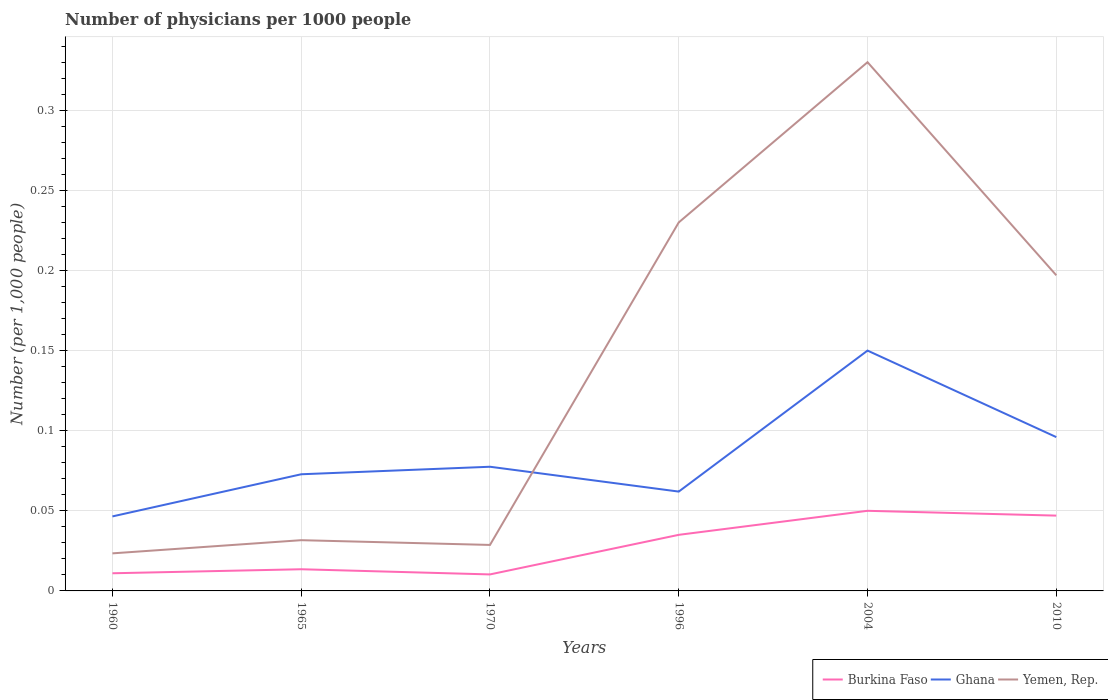How many different coloured lines are there?
Give a very brief answer. 3. Does the line corresponding to Yemen, Rep. intersect with the line corresponding to Ghana?
Make the answer very short. Yes. Is the number of lines equal to the number of legend labels?
Give a very brief answer. Yes. Across all years, what is the maximum number of physicians in Yemen, Rep.?
Offer a terse response. 0.02. What is the total number of physicians in Yemen, Rep. in the graph?
Offer a very short reply. -0.21. What is the difference between the highest and the second highest number of physicians in Ghana?
Make the answer very short. 0.1. How many lines are there?
Provide a succinct answer. 3. Are the values on the major ticks of Y-axis written in scientific E-notation?
Your response must be concise. No. Where does the legend appear in the graph?
Offer a very short reply. Bottom right. How many legend labels are there?
Your answer should be very brief. 3. What is the title of the graph?
Give a very brief answer. Number of physicians per 1000 people. Does "Spain" appear as one of the legend labels in the graph?
Your response must be concise. No. What is the label or title of the Y-axis?
Offer a very short reply. Number (per 1,0 people). What is the Number (per 1,000 people) of Burkina Faso in 1960?
Provide a succinct answer. 0.01. What is the Number (per 1,000 people) of Ghana in 1960?
Your answer should be compact. 0.05. What is the Number (per 1,000 people) of Yemen, Rep. in 1960?
Keep it short and to the point. 0.02. What is the Number (per 1,000 people) in Burkina Faso in 1965?
Provide a succinct answer. 0.01. What is the Number (per 1,000 people) of Ghana in 1965?
Keep it short and to the point. 0.07. What is the Number (per 1,000 people) in Yemen, Rep. in 1965?
Make the answer very short. 0.03. What is the Number (per 1,000 people) of Burkina Faso in 1970?
Make the answer very short. 0.01. What is the Number (per 1,000 people) in Ghana in 1970?
Ensure brevity in your answer.  0.08. What is the Number (per 1,000 people) in Yemen, Rep. in 1970?
Give a very brief answer. 0.03. What is the Number (per 1,000 people) of Burkina Faso in 1996?
Keep it short and to the point. 0.04. What is the Number (per 1,000 people) in Ghana in 1996?
Keep it short and to the point. 0.06. What is the Number (per 1,000 people) of Yemen, Rep. in 1996?
Your response must be concise. 0.23. What is the Number (per 1,000 people) in Burkina Faso in 2004?
Offer a terse response. 0.05. What is the Number (per 1,000 people) in Yemen, Rep. in 2004?
Provide a short and direct response. 0.33. What is the Number (per 1,000 people) of Burkina Faso in 2010?
Keep it short and to the point. 0.05. What is the Number (per 1,000 people) in Ghana in 2010?
Your answer should be very brief. 0.1. What is the Number (per 1,000 people) in Yemen, Rep. in 2010?
Your response must be concise. 0.2. Across all years, what is the maximum Number (per 1,000 people) in Burkina Faso?
Give a very brief answer. 0.05. Across all years, what is the maximum Number (per 1,000 people) of Ghana?
Offer a terse response. 0.15. Across all years, what is the maximum Number (per 1,000 people) of Yemen, Rep.?
Make the answer very short. 0.33. Across all years, what is the minimum Number (per 1,000 people) of Burkina Faso?
Your answer should be very brief. 0.01. Across all years, what is the minimum Number (per 1,000 people) in Ghana?
Provide a short and direct response. 0.05. Across all years, what is the minimum Number (per 1,000 people) of Yemen, Rep.?
Provide a short and direct response. 0.02. What is the total Number (per 1,000 people) of Burkina Faso in the graph?
Offer a terse response. 0.17. What is the total Number (per 1,000 people) in Ghana in the graph?
Keep it short and to the point. 0.5. What is the total Number (per 1,000 people) of Yemen, Rep. in the graph?
Your answer should be compact. 0.84. What is the difference between the Number (per 1,000 people) in Burkina Faso in 1960 and that in 1965?
Ensure brevity in your answer.  -0. What is the difference between the Number (per 1,000 people) of Ghana in 1960 and that in 1965?
Keep it short and to the point. -0.03. What is the difference between the Number (per 1,000 people) in Yemen, Rep. in 1960 and that in 1965?
Your answer should be compact. -0.01. What is the difference between the Number (per 1,000 people) in Burkina Faso in 1960 and that in 1970?
Your answer should be compact. 0. What is the difference between the Number (per 1,000 people) of Ghana in 1960 and that in 1970?
Make the answer very short. -0.03. What is the difference between the Number (per 1,000 people) in Yemen, Rep. in 1960 and that in 1970?
Your answer should be compact. -0.01. What is the difference between the Number (per 1,000 people) in Burkina Faso in 1960 and that in 1996?
Your answer should be compact. -0.02. What is the difference between the Number (per 1,000 people) of Ghana in 1960 and that in 1996?
Provide a short and direct response. -0.02. What is the difference between the Number (per 1,000 people) in Yemen, Rep. in 1960 and that in 1996?
Your answer should be compact. -0.21. What is the difference between the Number (per 1,000 people) in Burkina Faso in 1960 and that in 2004?
Your response must be concise. -0.04. What is the difference between the Number (per 1,000 people) in Ghana in 1960 and that in 2004?
Make the answer very short. -0.1. What is the difference between the Number (per 1,000 people) of Yemen, Rep. in 1960 and that in 2004?
Your answer should be compact. -0.31. What is the difference between the Number (per 1,000 people) in Burkina Faso in 1960 and that in 2010?
Ensure brevity in your answer.  -0.04. What is the difference between the Number (per 1,000 people) of Ghana in 1960 and that in 2010?
Provide a short and direct response. -0.05. What is the difference between the Number (per 1,000 people) in Yemen, Rep. in 1960 and that in 2010?
Your response must be concise. -0.17. What is the difference between the Number (per 1,000 people) of Burkina Faso in 1965 and that in 1970?
Your answer should be very brief. 0. What is the difference between the Number (per 1,000 people) in Ghana in 1965 and that in 1970?
Offer a terse response. -0. What is the difference between the Number (per 1,000 people) in Yemen, Rep. in 1965 and that in 1970?
Provide a short and direct response. 0. What is the difference between the Number (per 1,000 people) of Burkina Faso in 1965 and that in 1996?
Provide a short and direct response. -0.02. What is the difference between the Number (per 1,000 people) of Ghana in 1965 and that in 1996?
Offer a very short reply. 0.01. What is the difference between the Number (per 1,000 people) of Yemen, Rep. in 1965 and that in 1996?
Your response must be concise. -0.2. What is the difference between the Number (per 1,000 people) in Burkina Faso in 1965 and that in 2004?
Make the answer very short. -0.04. What is the difference between the Number (per 1,000 people) of Ghana in 1965 and that in 2004?
Give a very brief answer. -0.08. What is the difference between the Number (per 1,000 people) of Yemen, Rep. in 1965 and that in 2004?
Your answer should be compact. -0.3. What is the difference between the Number (per 1,000 people) of Burkina Faso in 1965 and that in 2010?
Make the answer very short. -0.03. What is the difference between the Number (per 1,000 people) of Ghana in 1965 and that in 2010?
Your answer should be compact. -0.02. What is the difference between the Number (per 1,000 people) of Yemen, Rep. in 1965 and that in 2010?
Provide a succinct answer. -0.17. What is the difference between the Number (per 1,000 people) in Burkina Faso in 1970 and that in 1996?
Provide a succinct answer. -0.02. What is the difference between the Number (per 1,000 people) in Ghana in 1970 and that in 1996?
Offer a terse response. 0.02. What is the difference between the Number (per 1,000 people) in Yemen, Rep. in 1970 and that in 1996?
Your answer should be very brief. -0.2. What is the difference between the Number (per 1,000 people) in Burkina Faso in 1970 and that in 2004?
Keep it short and to the point. -0.04. What is the difference between the Number (per 1,000 people) in Ghana in 1970 and that in 2004?
Offer a terse response. -0.07. What is the difference between the Number (per 1,000 people) of Yemen, Rep. in 1970 and that in 2004?
Your answer should be very brief. -0.3. What is the difference between the Number (per 1,000 people) in Burkina Faso in 1970 and that in 2010?
Offer a very short reply. -0.04. What is the difference between the Number (per 1,000 people) in Ghana in 1970 and that in 2010?
Ensure brevity in your answer.  -0.02. What is the difference between the Number (per 1,000 people) in Yemen, Rep. in 1970 and that in 2010?
Your answer should be compact. -0.17. What is the difference between the Number (per 1,000 people) of Burkina Faso in 1996 and that in 2004?
Your answer should be compact. -0.01. What is the difference between the Number (per 1,000 people) in Ghana in 1996 and that in 2004?
Offer a terse response. -0.09. What is the difference between the Number (per 1,000 people) in Yemen, Rep. in 1996 and that in 2004?
Offer a terse response. -0.1. What is the difference between the Number (per 1,000 people) in Burkina Faso in 1996 and that in 2010?
Make the answer very short. -0.01. What is the difference between the Number (per 1,000 people) in Ghana in 1996 and that in 2010?
Provide a succinct answer. -0.03. What is the difference between the Number (per 1,000 people) in Yemen, Rep. in 1996 and that in 2010?
Ensure brevity in your answer.  0.03. What is the difference between the Number (per 1,000 people) of Burkina Faso in 2004 and that in 2010?
Ensure brevity in your answer.  0. What is the difference between the Number (per 1,000 people) in Ghana in 2004 and that in 2010?
Keep it short and to the point. 0.05. What is the difference between the Number (per 1,000 people) of Yemen, Rep. in 2004 and that in 2010?
Offer a very short reply. 0.13. What is the difference between the Number (per 1,000 people) in Burkina Faso in 1960 and the Number (per 1,000 people) in Ghana in 1965?
Your answer should be very brief. -0.06. What is the difference between the Number (per 1,000 people) in Burkina Faso in 1960 and the Number (per 1,000 people) in Yemen, Rep. in 1965?
Provide a short and direct response. -0.02. What is the difference between the Number (per 1,000 people) of Ghana in 1960 and the Number (per 1,000 people) of Yemen, Rep. in 1965?
Keep it short and to the point. 0.01. What is the difference between the Number (per 1,000 people) of Burkina Faso in 1960 and the Number (per 1,000 people) of Ghana in 1970?
Offer a terse response. -0.07. What is the difference between the Number (per 1,000 people) of Burkina Faso in 1960 and the Number (per 1,000 people) of Yemen, Rep. in 1970?
Your response must be concise. -0.02. What is the difference between the Number (per 1,000 people) of Ghana in 1960 and the Number (per 1,000 people) of Yemen, Rep. in 1970?
Keep it short and to the point. 0.02. What is the difference between the Number (per 1,000 people) of Burkina Faso in 1960 and the Number (per 1,000 people) of Ghana in 1996?
Provide a short and direct response. -0.05. What is the difference between the Number (per 1,000 people) in Burkina Faso in 1960 and the Number (per 1,000 people) in Yemen, Rep. in 1996?
Keep it short and to the point. -0.22. What is the difference between the Number (per 1,000 people) of Ghana in 1960 and the Number (per 1,000 people) of Yemen, Rep. in 1996?
Provide a short and direct response. -0.18. What is the difference between the Number (per 1,000 people) in Burkina Faso in 1960 and the Number (per 1,000 people) in Ghana in 2004?
Provide a succinct answer. -0.14. What is the difference between the Number (per 1,000 people) of Burkina Faso in 1960 and the Number (per 1,000 people) of Yemen, Rep. in 2004?
Offer a terse response. -0.32. What is the difference between the Number (per 1,000 people) of Ghana in 1960 and the Number (per 1,000 people) of Yemen, Rep. in 2004?
Give a very brief answer. -0.28. What is the difference between the Number (per 1,000 people) in Burkina Faso in 1960 and the Number (per 1,000 people) in Ghana in 2010?
Your answer should be compact. -0.09. What is the difference between the Number (per 1,000 people) in Burkina Faso in 1960 and the Number (per 1,000 people) in Yemen, Rep. in 2010?
Provide a short and direct response. -0.19. What is the difference between the Number (per 1,000 people) of Ghana in 1960 and the Number (per 1,000 people) of Yemen, Rep. in 2010?
Make the answer very short. -0.15. What is the difference between the Number (per 1,000 people) of Burkina Faso in 1965 and the Number (per 1,000 people) of Ghana in 1970?
Ensure brevity in your answer.  -0.06. What is the difference between the Number (per 1,000 people) in Burkina Faso in 1965 and the Number (per 1,000 people) in Yemen, Rep. in 1970?
Give a very brief answer. -0.02. What is the difference between the Number (per 1,000 people) of Ghana in 1965 and the Number (per 1,000 people) of Yemen, Rep. in 1970?
Offer a terse response. 0.04. What is the difference between the Number (per 1,000 people) of Burkina Faso in 1965 and the Number (per 1,000 people) of Ghana in 1996?
Your answer should be very brief. -0.05. What is the difference between the Number (per 1,000 people) in Burkina Faso in 1965 and the Number (per 1,000 people) in Yemen, Rep. in 1996?
Your response must be concise. -0.22. What is the difference between the Number (per 1,000 people) in Ghana in 1965 and the Number (per 1,000 people) in Yemen, Rep. in 1996?
Your response must be concise. -0.16. What is the difference between the Number (per 1,000 people) in Burkina Faso in 1965 and the Number (per 1,000 people) in Ghana in 2004?
Offer a terse response. -0.14. What is the difference between the Number (per 1,000 people) in Burkina Faso in 1965 and the Number (per 1,000 people) in Yemen, Rep. in 2004?
Give a very brief answer. -0.32. What is the difference between the Number (per 1,000 people) in Ghana in 1965 and the Number (per 1,000 people) in Yemen, Rep. in 2004?
Give a very brief answer. -0.26. What is the difference between the Number (per 1,000 people) in Burkina Faso in 1965 and the Number (per 1,000 people) in Ghana in 2010?
Ensure brevity in your answer.  -0.08. What is the difference between the Number (per 1,000 people) in Burkina Faso in 1965 and the Number (per 1,000 people) in Yemen, Rep. in 2010?
Keep it short and to the point. -0.18. What is the difference between the Number (per 1,000 people) in Ghana in 1965 and the Number (per 1,000 people) in Yemen, Rep. in 2010?
Provide a succinct answer. -0.12. What is the difference between the Number (per 1,000 people) of Burkina Faso in 1970 and the Number (per 1,000 people) of Ghana in 1996?
Give a very brief answer. -0.05. What is the difference between the Number (per 1,000 people) of Burkina Faso in 1970 and the Number (per 1,000 people) of Yemen, Rep. in 1996?
Make the answer very short. -0.22. What is the difference between the Number (per 1,000 people) in Ghana in 1970 and the Number (per 1,000 people) in Yemen, Rep. in 1996?
Ensure brevity in your answer.  -0.15. What is the difference between the Number (per 1,000 people) of Burkina Faso in 1970 and the Number (per 1,000 people) of Ghana in 2004?
Your response must be concise. -0.14. What is the difference between the Number (per 1,000 people) of Burkina Faso in 1970 and the Number (per 1,000 people) of Yemen, Rep. in 2004?
Your answer should be very brief. -0.32. What is the difference between the Number (per 1,000 people) of Ghana in 1970 and the Number (per 1,000 people) of Yemen, Rep. in 2004?
Offer a terse response. -0.25. What is the difference between the Number (per 1,000 people) in Burkina Faso in 1970 and the Number (per 1,000 people) in Ghana in 2010?
Offer a terse response. -0.09. What is the difference between the Number (per 1,000 people) in Burkina Faso in 1970 and the Number (per 1,000 people) in Yemen, Rep. in 2010?
Offer a very short reply. -0.19. What is the difference between the Number (per 1,000 people) of Ghana in 1970 and the Number (per 1,000 people) of Yemen, Rep. in 2010?
Ensure brevity in your answer.  -0.12. What is the difference between the Number (per 1,000 people) of Burkina Faso in 1996 and the Number (per 1,000 people) of Ghana in 2004?
Your answer should be compact. -0.12. What is the difference between the Number (per 1,000 people) in Burkina Faso in 1996 and the Number (per 1,000 people) in Yemen, Rep. in 2004?
Provide a short and direct response. -0.29. What is the difference between the Number (per 1,000 people) of Ghana in 1996 and the Number (per 1,000 people) of Yemen, Rep. in 2004?
Make the answer very short. -0.27. What is the difference between the Number (per 1,000 people) of Burkina Faso in 1996 and the Number (per 1,000 people) of Ghana in 2010?
Provide a succinct answer. -0.06. What is the difference between the Number (per 1,000 people) in Burkina Faso in 1996 and the Number (per 1,000 people) in Yemen, Rep. in 2010?
Provide a succinct answer. -0.16. What is the difference between the Number (per 1,000 people) of Ghana in 1996 and the Number (per 1,000 people) of Yemen, Rep. in 2010?
Ensure brevity in your answer.  -0.14. What is the difference between the Number (per 1,000 people) of Burkina Faso in 2004 and the Number (per 1,000 people) of Ghana in 2010?
Make the answer very short. -0.05. What is the difference between the Number (per 1,000 people) in Burkina Faso in 2004 and the Number (per 1,000 people) in Yemen, Rep. in 2010?
Your response must be concise. -0.15. What is the difference between the Number (per 1,000 people) in Ghana in 2004 and the Number (per 1,000 people) in Yemen, Rep. in 2010?
Offer a terse response. -0.05. What is the average Number (per 1,000 people) of Burkina Faso per year?
Ensure brevity in your answer.  0.03. What is the average Number (per 1,000 people) in Ghana per year?
Your response must be concise. 0.08. What is the average Number (per 1,000 people) in Yemen, Rep. per year?
Ensure brevity in your answer.  0.14. In the year 1960, what is the difference between the Number (per 1,000 people) of Burkina Faso and Number (per 1,000 people) of Ghana?
Your answer should be compact. -0.04. In the year 1960, what is the difference between the Number (per 1,000 people) in Burkina Faso and Number (per 1,000 people) in Yemen, Rep.?
Provide a short and direct response. -0.01. In the year 1960, what is the difference between the Number (per 1,000 people) of Ghana and Number (per 1,000 people) of Yemen, Rep.?
Your answer should be compact. 0.02. In the year 1965, what is the difference between the Number (per 1,000 people) of Burkina Faso and Number (per 1,000 people) of Ghana?
Ensure brevity in your answer.  -0.06. In the year 1965, what is the difference between the Number (per 1,000 people) of Burkina Faso and Number (per 1,000 people) of Yemen, Rep.?
Your answer should be compact. -0.02. In the year 1965, what is the difference between the Number (per 1,000 people) in Ghana and Number (per 1,000 people) in Yemen, Rep.?
Provide a succinct answer. 0.04. In the year 1970, what is the difference between the Number (per 1,000 people) in Burkina Faso and Number (per 1,000 people) in Ghana?
Provide a succinct answer. -0.07. In the year 1970, what is the difference between the Number (per 1,000 people) of Burkina Faso and Number (per 1,000 people) of Yemen, Rep.?
Give a very brief answer. -0.02. In the year 1970, what is the difference between the Number (per 1,000 people) of Ghana and Number (per 1,000 people) of Yemen, Rep.?
Provide a succinct answer. 0.05. In the year 1996, what is the difference between the Number (per 1,000 people) of Burkina Faso and Number (per 1,000 people) of Ghana?
Offer a terse response. -0.03. In the year 1996, what is the difference between the Number (per 1,000 people) of Burkina Faso and Number (per 1,000 people) of Yemen, Rep.?
Ensure brevity in your answer.  -0.2. In the year 1996, what is the difference between the Number (per 1,000 people) in Ghana and Number (per 1,000 people) in Yemen, Rep.?
Provide a succinct answer. -0.17. In the year 2004, what is the difference between the Number (per 1,000 people) in Burkina Faso and Number (per 1,000 people) in Yemen, Rep.?
Offer a terse response. -0.28. In the year 2004, what is the difference between the Number (per 1,000 people) in Ghana and Number (per 1,000 people) in Yemen, Rep.?
Provide a short and direct response. -0.18. In the year 2010, what is the difference between the Number (per 1,000 people) in Burkina Faso and Number (per 1,000 people) in Ghana?
Your answer should be compact. -0.05. In the year 2010, what is the difference between the Number (per 1,000 people) of Ghana and Number (per 1,000 people) of Yemen, Rep.?
Offer a very short reply. -0.1. What is the ratio of the Number (per 1,000 people) in Burkina Faso in 1960 to that in 1965?
Your answer should be compact. 0.81. What is the ratio of the Number (per 1,000 people) of Ghana in 1960 to that in 1965?
Keep it short and to the point. 0.64. What is the ratio of the Number (per 1,000 people) in Yemen, Rep. in 1960 to that in 1965?
Keep it short and to the point. 0.74. What is the ratio of the Number (per 1,000 people) of Burkina Faso in 1960 to that in 1970?
Provide a short and direct response. 1.07. What is the ratio of the Number (per 1,000 people) in Yemen, Rep. in 1960 to that in 1970?
Provide a succinct answer. 0.82. What is the ratio of the Number (per 1,000 people) in Burkina Faso in 1960 to that in 1996?
Your answer should be compact. 0.31. What is the ratio of the Number (per 1,000 people) of Ghana in 1960 to that in 1996?
Offer a very short reply. 0.75. What is the ratio of the Number (per 1,000 people) of Yemen, Rep. in 1960 to that in 1996?
Keep it short and to the point. 0.1. What is the ratio of the Number (per 1,000 people) of Burkina Faso in 1960 to that in 2004?
Your response must be concise. 0.22. What is the ratio of the Number (per 1,000 people) in Ghana in 1960 to that in 2004?
Keep it short and to the point. 0.31. What is the ratio of the Number (per 1,000 people) of Yemen, Rep. in 1960 to that in 2004?
Offer a very short reply. 0.07. What is the ratio of the Number (per 1,000 people) in Burkina Faso in 1960 to that in 2010?
Provide a short and direct response. 0.23. What is the ratio of the Number (per 1,000 people) in Ghana in 1960 to that in 2010?
Offer a terse response. 0.48. What is the ratio of the Number (per 1,000 people) in Yemen, Rep. in 1960 to that in 2010?
Offer a terse response. 0.12. What is the ratio of the Number (per 1,000 people) of Burkina Faso in 1965 to that in 1970?
Provide a succinct answer. 1.31. What is the ratio of the Number (per 1,000 people) in Ghana in 1965 to that in 1970?
Offer a terse response. 0.94. What is the ratio of the Number (per 1,000 people) of Yemen, Rep. in 1965 to that in 1970?
Your response must be concise. 1.1. What is the ratio of the Number (per 1,000 people) of Burkina Faso in 1965 to that in 1996?
Keep it short and to the point. 0.39. What is the ratio of the Number (per 1,000 people) of Ghana in 1965 to that in 1996?
Make the answer very short. 1.17. What is the ratio of the Number (per 1,000 people) of Yemen, Rep. in 1965 to that in 1996?
Your answer should be very brief. 0.14. What is the ratio of the Number (per 1,000 people) in Burkina Faso in 1965 to that in 2004?
Your answer should be compact. 0.27. What is the ratio of the Number (per 1,000 people) in Ghana in 1965 to that in 2004?
Your response must be concise. 0.49. What is the ratio of the Number (per 1,000 people) of Yemen, Rep. in 1965 to that in 2004?
Provide a short and direct response. 0.1. What is the ratio of the Number (per 1,000 people) in Burkina Faso in 1965 to that in 2010?
Provide a succinct answer. 0.29. What is the ratio of the Number (per 1,000 people) of Ghana in 1965 to that in 2010?
Keep it short and to the point. 0.76. What is the ratio of the Number (per 1,000 people) in Yemen, Rep. in 1965 to that in 2010?
Offer a very short reply. 0.16. What is the ratio of the Number (per 1,000 people) of Burkina Faso in 1970 to that in 1996?
Your answer should be compact. 0.29. What is the ratio of the Number (per 1,000 people) of Ghana in 1970 to that in 1996?
Provide a succinct answer. 1.25. What is the ratio of the Number (per 1,000 people) in Yemen, Rep. in 1970 to that in 1996?
Provide a succinct answer. 0.12. What is the ratio of the Number (per 1,000 people) in Burkina Faso in 1970 to that in 2004?
Ensure brevity in your answer.  0.21. What is the ratio of the Number (per 1,000 people) in Ghana in 1970 to that in 2004?
Offer a very short reply. 0.52. What is the ratio of the Number (per 1,000 people) in Yemen, Rep. in 1970 to that in 2004?
Your answer should be very brief. 0.09. What is the ratio of the Number (per 1,000 people) in Burkina Faso in 1970 to that in 2010?
Make the answer very short. 0.22. What is the ratio of the Number (per 1,000 people) of Ghana in 1970 to that in 2010?
Your answer should be compact. 0.81. What is the ratio of the Number (per 1,000 people) in Yemen, Rep. in 1970 to that in 2010?
Make the answer very short. 0.15. What is the ratio of the Number (per 1,000 people) in Ghana in 1996 to that in 2004?
Make the answer very short. 0.41. What is the ratio of the Number (per 1,000 people) of Yemen, Rep. in 1996 to that in 2004?
Your answer should be very brief. 0.7. What is the ratio of the Number (per 1,000 people) of Burkina Faso in 1996 to that in 2010?
Provide a short and direct response. 0.74. What is the ratio of the Number (per 1,000 people) in Ghana in 1996 to that in 2010?
Give a very brief answer. 0.65. What is the ratio of the Number (per 1,000 people) of Yemen, Rep. in 1996 to that in 2010?
Your answer should be compact. 1.17. What is the ratio of the Number (per 1,000 people) of Burkina Faso in 2004 to that in 2010?
Offer a very short reply. 1.06. What is the ratio of the Number (per 1,000 people) of Ghana in 2004 to that in 2010?
Your answer should be compact. 1.56. What is the ratio of the Number (per 1,000 people) of Yemen, Rep. in 2004 to that in 2010?
Provide a short and direct response. 1.68. What is the difference between the highest and the second highest Number (per 1,000 people) in Burkina Faso?
Your answer should be very brief. 0. What is the difference between the highest and the second highest Number (per 1,000 people) in Ghana?
Your answer should be very brief. 0.05. What is the difference between the highest and the second highest Number (per 1,000 people) of Yemen, Rep.?
Ensure brevity in your answer.  0.1. What is the difference between the highest and the lowest Number (per 1,000 people) of Burkina Faso?
Your response must be concise. 0.04. What is the difference between the highest and the lowest Number (per 1,000 people) in Ghana?
Your answer should be very brief. 0.1. What is the difference between the highest and the lowest Number (per 1,000 people) of Yemen, Rep.?
Offer a very short reply. 0.31. 